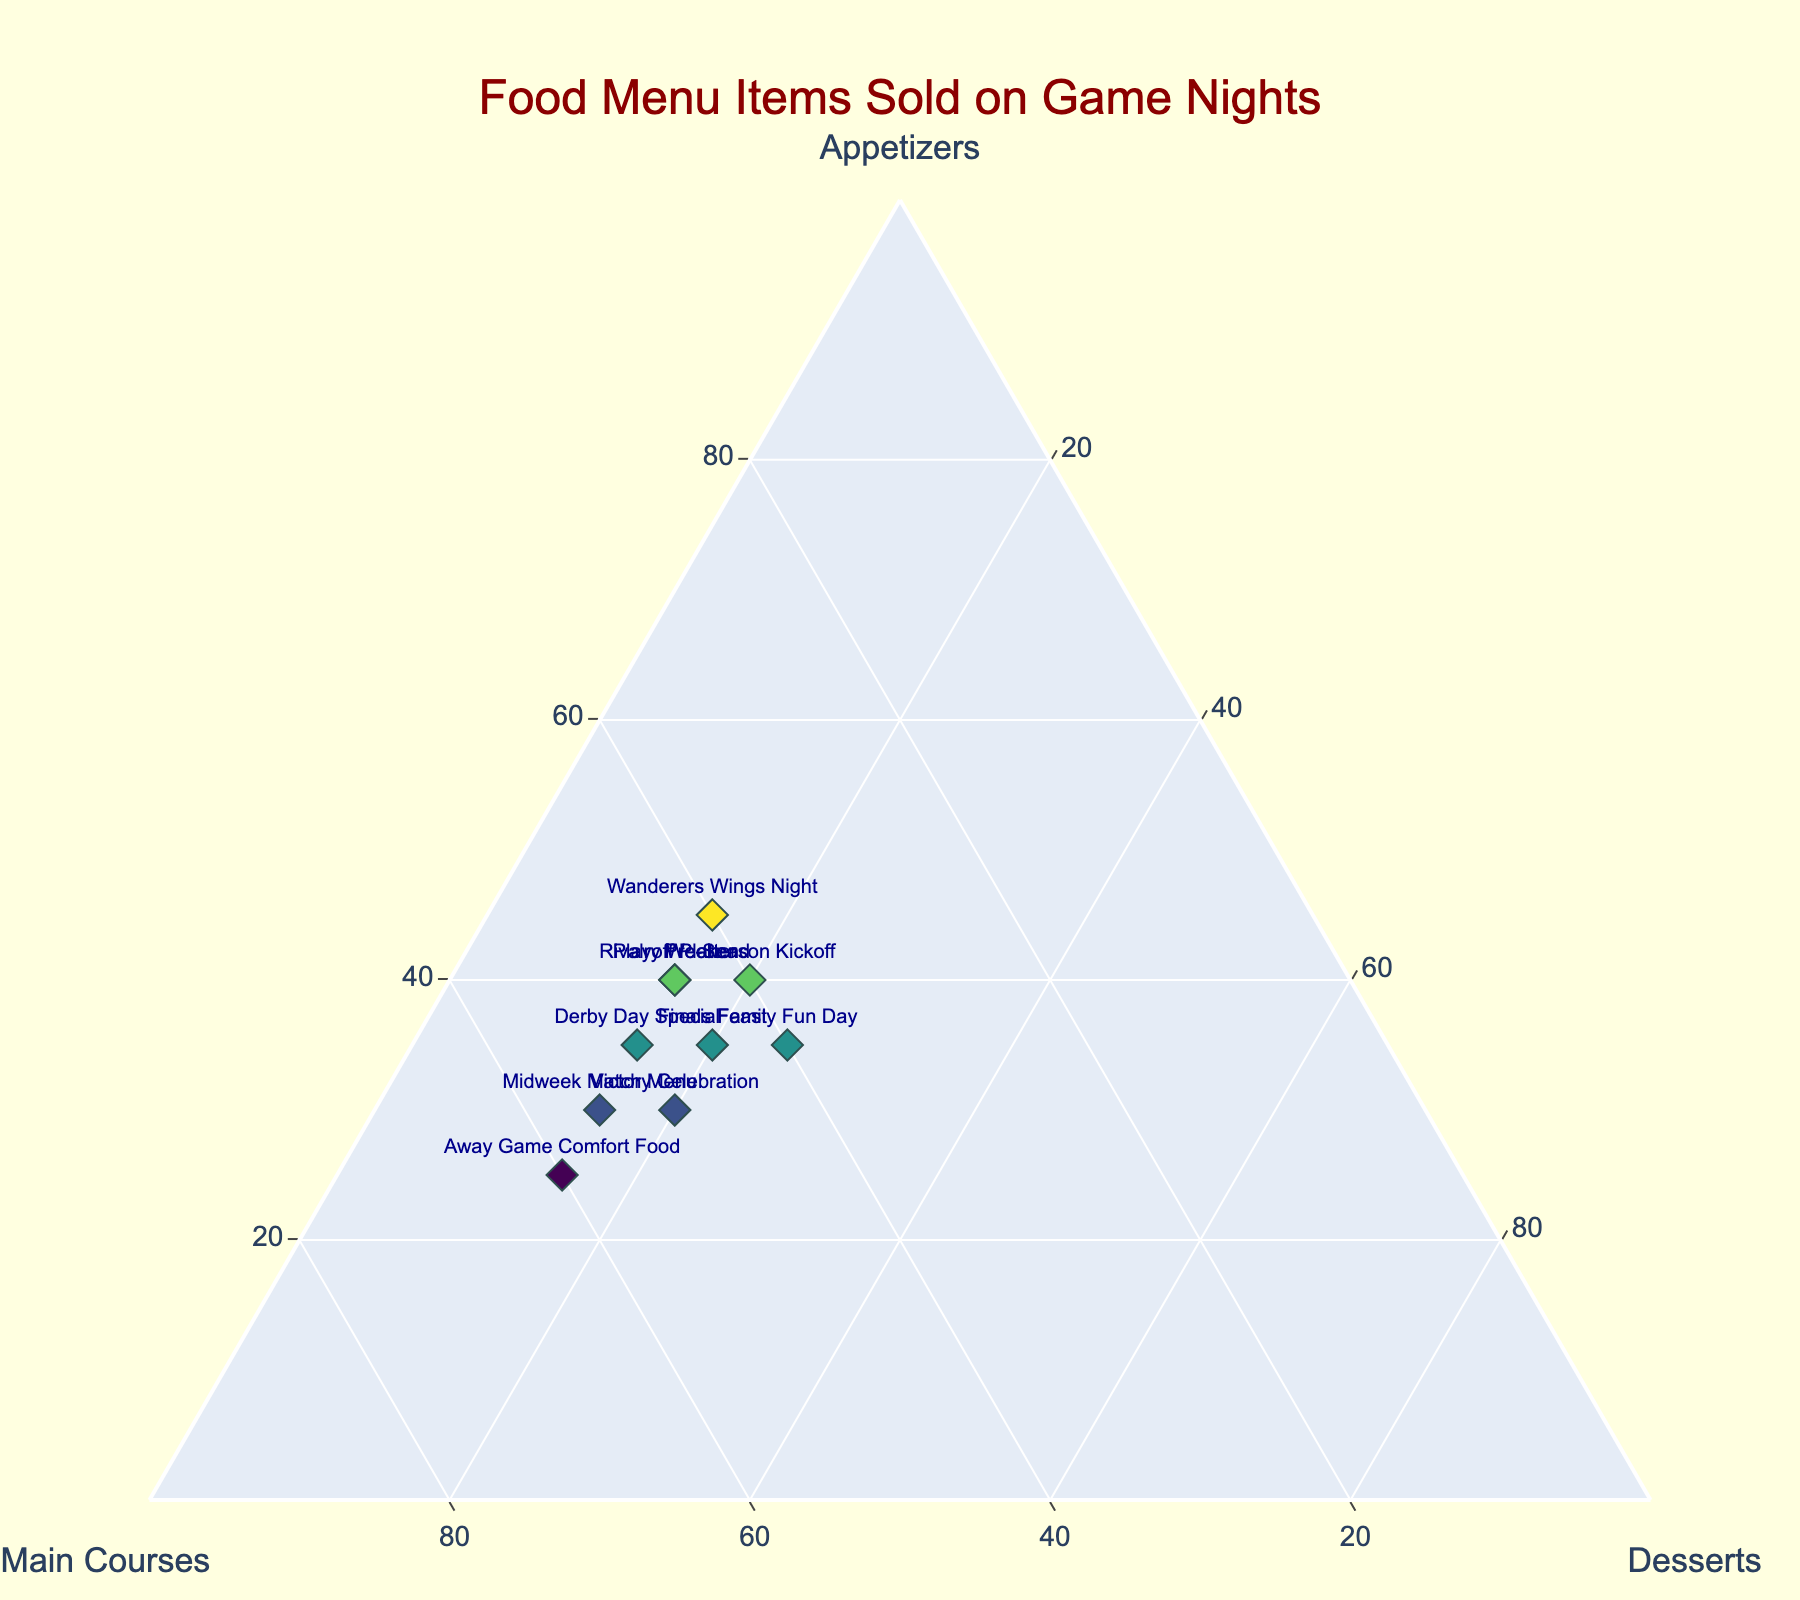What's the title of the figure? The title is displayed at the top center of the figure, which reads "Food Menu Items Sold on Game Nights".
Answer: Food Menu Items Sold on Game Nights How many different menu item labels are there on this plot? Each data point has a unique label and represents one menu item. By counting the labels, we find there are 10 distinct menu items.
Answer: 10 Which menu item sold the highest percentage of main courses? To determine this, we need to find the data point farthest along the "Main Courses" axis. "Away Game Comfort Food" has the highest value for main courses at 60%.
Answer: Away Game Comfort Food What is the sum of the percentages for appetizers and desserts for "Finals Feast"? For "Finals Feast", the appetizers percentage is 35% and desserts percentage is 20%. Summing these gives: 35 + 20 = 55%.
Answer: 55% Which menu item has equal percentages of appetizers and main courses? We look for a data point where the values of appetizers and main courses are the same. "Wanderers Wings Night", "Pre-Season Kickoff", and "Family Fun Day" all have this characteristic with 40% each for appetizers and main courses.
Answer: Wanderers Wings Night, Pre-Season Kickoff, Family Fun Day What percentage of desserts were sold during "Family Fun Day"? We need to find the data point labeled "Family Fun Day" and check the percentage value for desserts, which is 25%.
Answer: 25% Between "Derby Day Special" and "Victory Celebration", which had a higher percentage of appetizers sold? Comparing the appetizers percentages, "Derby Day Special" has 35% while "Victory Celebration" has 30%. Therefore, "Derby Day Special" had a higher percentage of appetizers sold.
Answer: Derby Day Special Which menu items have a desserts percentage of 15%? We find data points with 15% for desserts. The menu items are "Wanderers Wings Night", "Derby Day Special", "Playoff Platter", "Midweek Match Menu", "Away Game Comfort Food", and "Rivalry Weekend".
Answer: Wanderers Wings Night, Derby Day Special, Playoff Platter, Midweek Match Menu, Away Game Comfort Food, Rivalry Weekend What is the average percentage of main courses sold across all menu items? Adding the percentages for main courses across all menu items gives: 40 + 50 + 45 + 55 + 45 + 60 + 40 + 50 + 40 + 45 = 470. Dividing by the number of menu items (10) gives the average of 470/10 = 47%.
Answer: 47% 